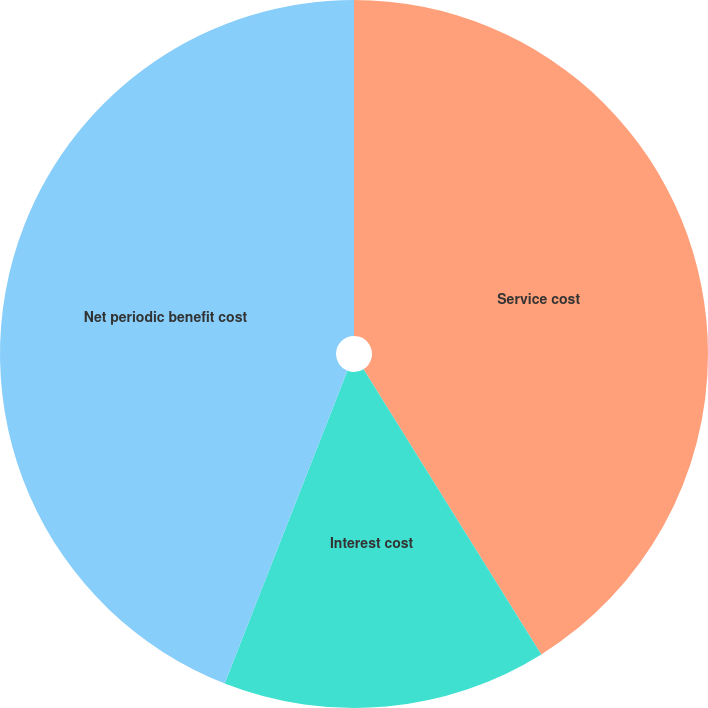<chart> <loc_0><loc_0><loc_500><loc_500><pie_chart><fcel>Service cost<fcel>Interest cost<fcel>Net periodic benefit cost<nl><fcel>41.13%<fcel>14.83%<fcel>44.05%<nl></chart> 